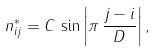<formula> <loc_0><loc_0><loc_500><loc_500>n ^ { * } _ { i j } = C \, \sin \left | \pi \, \frac { j - i } { D } \right | ,</formula> 